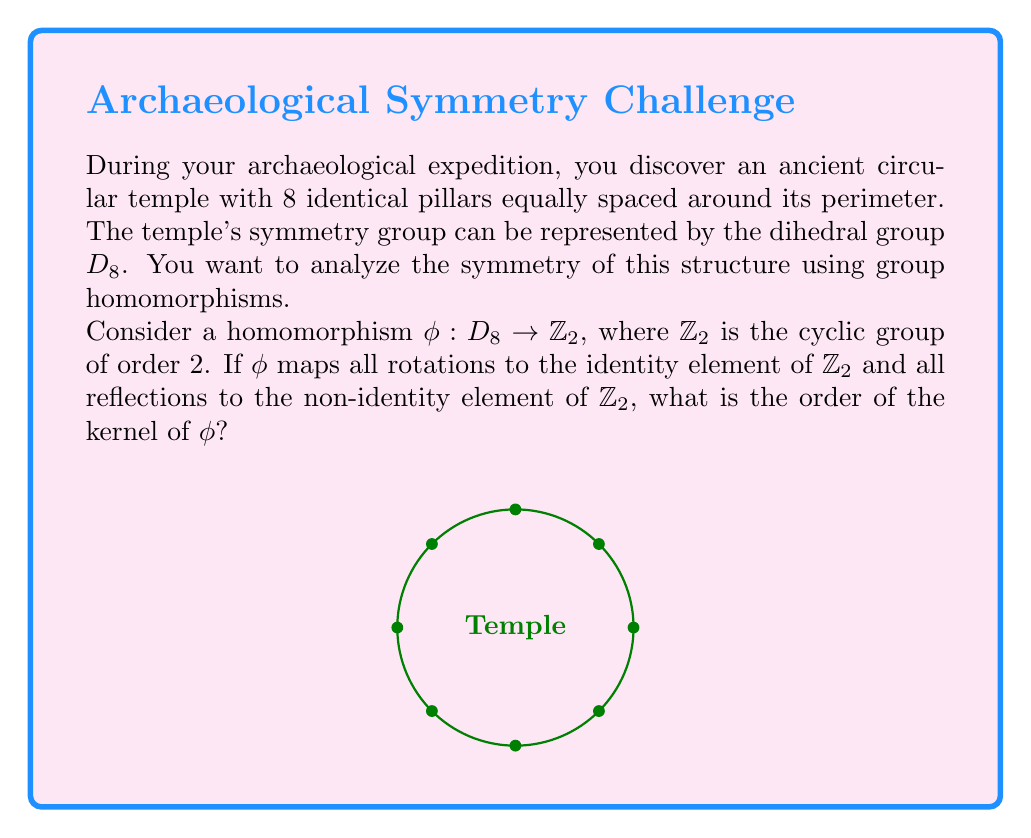What is the answer to this math problem? Let's approach this step-by-step:

1) First, recall that $D_8$ has 16 elements: 8 rotations (including the identity) and 8 reflections.

2) The homomorphism $\phi: D_8 \rightarrow \mathbb{Z}_2$ is defined as:
   $$\phi(r) = e_{\mathbb{Z}_2} \text{ for all rotations } r$$
   $$\phi(s) = a_{\mathbb{Z}_2} \text{ for all reflections } s$$
   where $e_{\mathbb{Z}_2}$ is the identity element and $a_{\mathbb{Z}_2}$ is the non-identity element of $\mathbb{Z}_2$.

3) The kernel of a homomorphism is the set of all elements that map to the identity element in the codomain. In this case:
   $$\ker(\phi) = \{x \in D_8 : \phi(x) = e_{\mathbb{Z}_2}\}$$

4) From the definition of $\phi$, we can see that all rotations in $D_8$ map to $e_{\mathbb{Z}_2}$.

5) The number of rotations in $D_8$ is 8 (including the identity rotation).

6) Therefore, the kernel of $\phi$ consists of all 8 rotations in $D_8$.

7) The order of a group is the number of elements in the group. So, the order of $\ker(\phi)$ is 8.
Answer: 8 